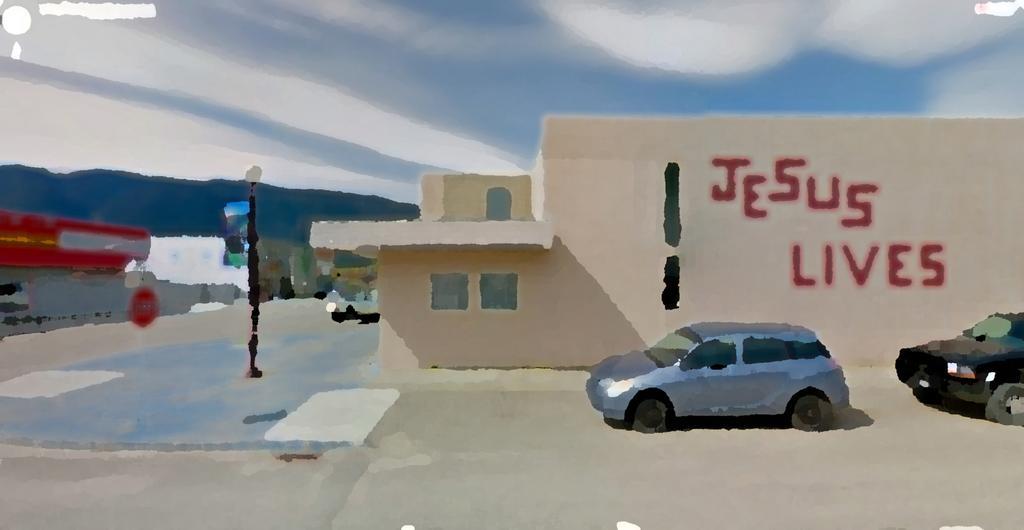How would you summarize this image in a sentence or two? This picture shows a painting and we see buildings and few cars and a pole and we see text on the wall of the building and we see a blue cloudy Sky. 